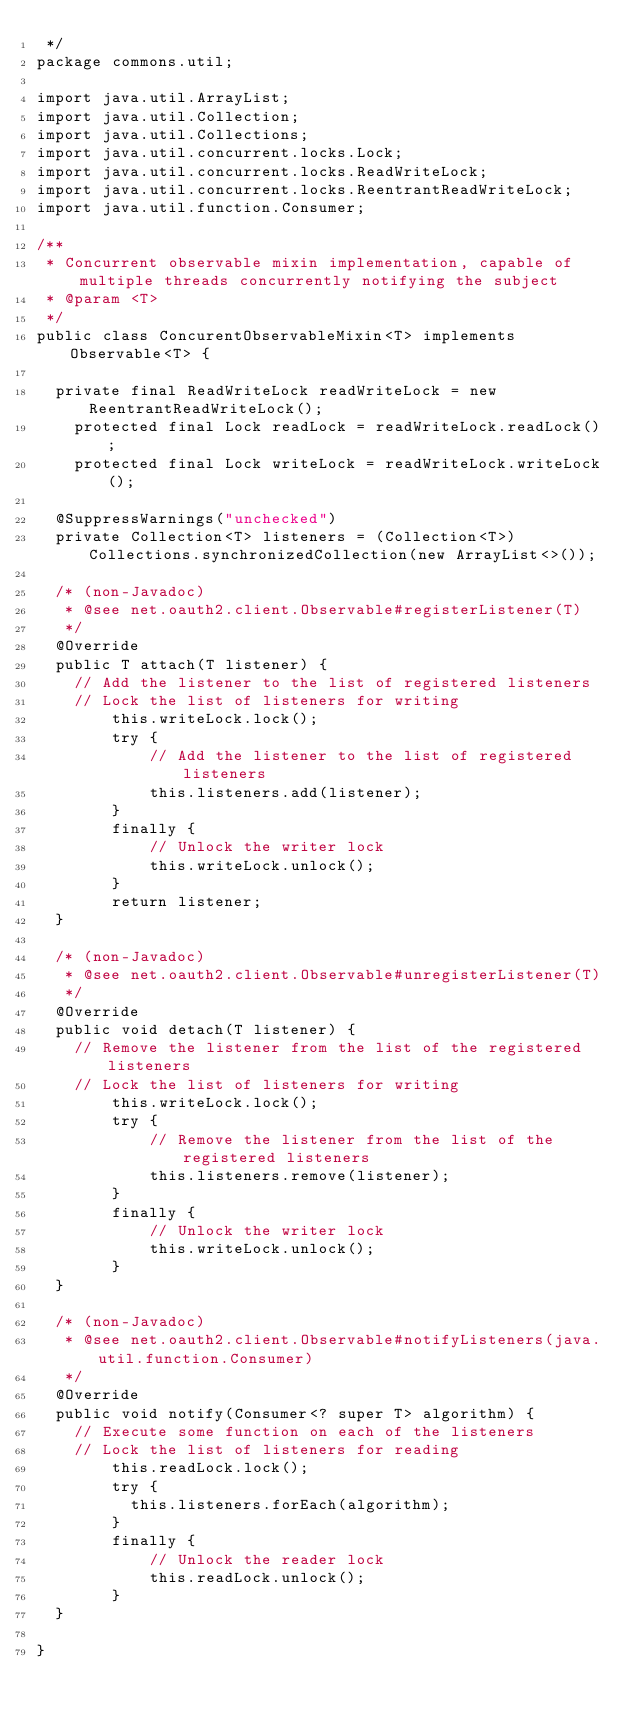Convert code to text. <code><loc_0><loc_0><loc_500><loc_500><_Java_> */
package commons.util;

import java.util.ArrayList;
import java.util.Collection;
import java.util.Collections;
import java.util.concurrent.locks.Lock;
import java.util.concurrent.locks.ReadWriteLock;
import java.util.concurrent.locks.ReentrantReadWriteLock;
import java.util.function.Consumer;

/**
 * Concurrent observable mixin implementation, capable of multiple threads concurrently notifying the subject
 * @param <T>
 */
public class ConcurentObservableMixin<T> implements Observable<T> {

	private final ReadWriteLock readWriteLock = new ReentrantReadWriteLock();
    protected final Lock readLock = readWriteLock.readLock();
    protected final Lock writeLock = readWriteLock.writeLock();
	
	@SuppressWarnings("unchecked")
	private Collection<T> listeners = (Collection<T>) Collections.synchronizedCollection(new ArrayList<>());

	/* (non-Javadoc)
	 * @see net.oauth2.client.Observable#registerListener(T)
	 */
	@Override
	public T attach(T listener) {
		// Add the listener to the list of registered listeners
		// Lock the list of listeners for writing
        this.writeLock.lock();
        try {
            // Add the listener to the list of registered listeners
            this.listeners.add(listener);
        }
        finally {
            // Unlock the writer lock
            this.writeLock.unlock();
        }
        return listener;
	}

	/* (non-Javadoc)
	 * @see net.oauth2.client.Observable#unregisterListener(T)
	 */
	@Override
	public void detach(T listener) {
		// Remove the listener from the list of the registered listeners
		// Lock the list of listeners for writing
        this.writeLock.lock();
        try {
            // Remove the listener from the list of the registered listeners
            this.listeners.remove(listener);
        }
        finally {
            // Unlock the writer lock
            this.writeLock.unlock();
        }
	}

	/* (non-Javadoc)
	 * @see net.oauth2.client.Observable#notifyListeners(java.util.function.Consumer)
	 */
	@Override
	public void notify(Consumer<? super T> algorithm) {
		// Execute some function on each of the listeners
		// Lock the list of listeners for reading
        this.readLock.lock();
        try {
        	this.listeners.forEach(algorithm);
        }
        finally {
            // Unlock the reader lock
            this.readLock.unlock();
        }
	}

}
</code> 